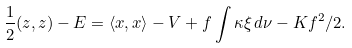<formula> <loc_0><loc_0><loc_500><loc_500>\frac { 1 } { 2 } ( z , z ) - E = \langle x , x \rangle - V + f \int \kappa \xi \, d \nu - K f ^ { 2 } / 2 .</formula> 